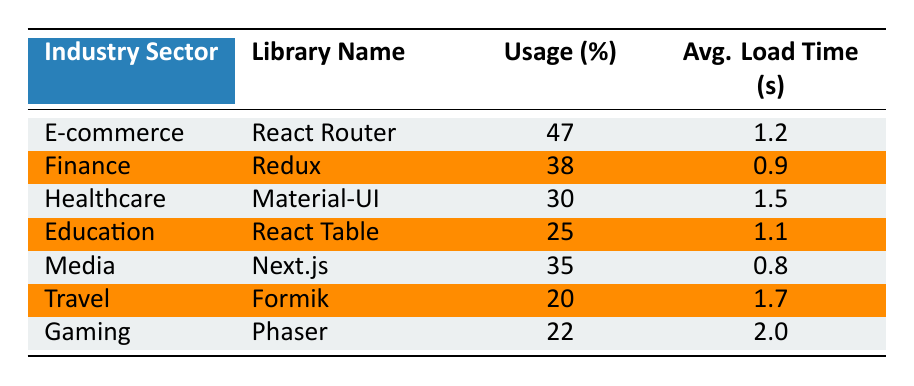What is the usage percentage of React Router in the E-commerce sector? The table shows that in the E-commerce sector, the library used is React Router with a usage percentage of 47.
Answer: 47 Which library has the highest usage percentage in the Finance sector? According to the table, in the Finance sector, the library with the highest usage percentage is Redux at 38.
Answer: Redux What is the average load time for Material-UI in the Healthcare sector? The table indicates that the average load time for Material-UI, which is used in the Healthcare sector, is 1.5 seconds.
Answer: 1.5 If we combine the usage percentages of React Table and Formik, what is the total? React Table has a usage percentage of 25, and Formik has 20. Adding these together: 25 + 20 = 45.
Answer: 45 Is it true that Next.js has a lower average load time than Formik? The table lists Next.js with an average load time of 0.8 seconds, while Formik has an average load time of 1.7 seconds. Since 0.8 is less than 1.7, the statement is true.
Answer: Yes Which library has the second highest usage percentage in the table, and what is that percentage? Upon examining the table, Redux comes second with a usage percentage of 38, while React Router is the highest at 47. Thus, Redux is the answer.
Answer: Redux, 38 What is the difference in average load times between the Media and Gaming sectors? The average load time for Next.js in the Media sector is 0.8 seconds, and for Phaser in the Gaming sector, it is 2.0 seconds. Therefore, we calculate the difference as: 2.0 - 0.8 = 1.2 seconds.
Answer: 1.2 In how many industry sectors is the library Formik being used? The table indicates that Formik is used only in the Travel sector. Hence, there is just one sector where Formik is present.
Answer: 1 Which library has the lowest usage percentage in the provided data? Looking through the table, Formik has the lowest usage percentage at 20 among all listed libraries.
Answer: Formik, 20 